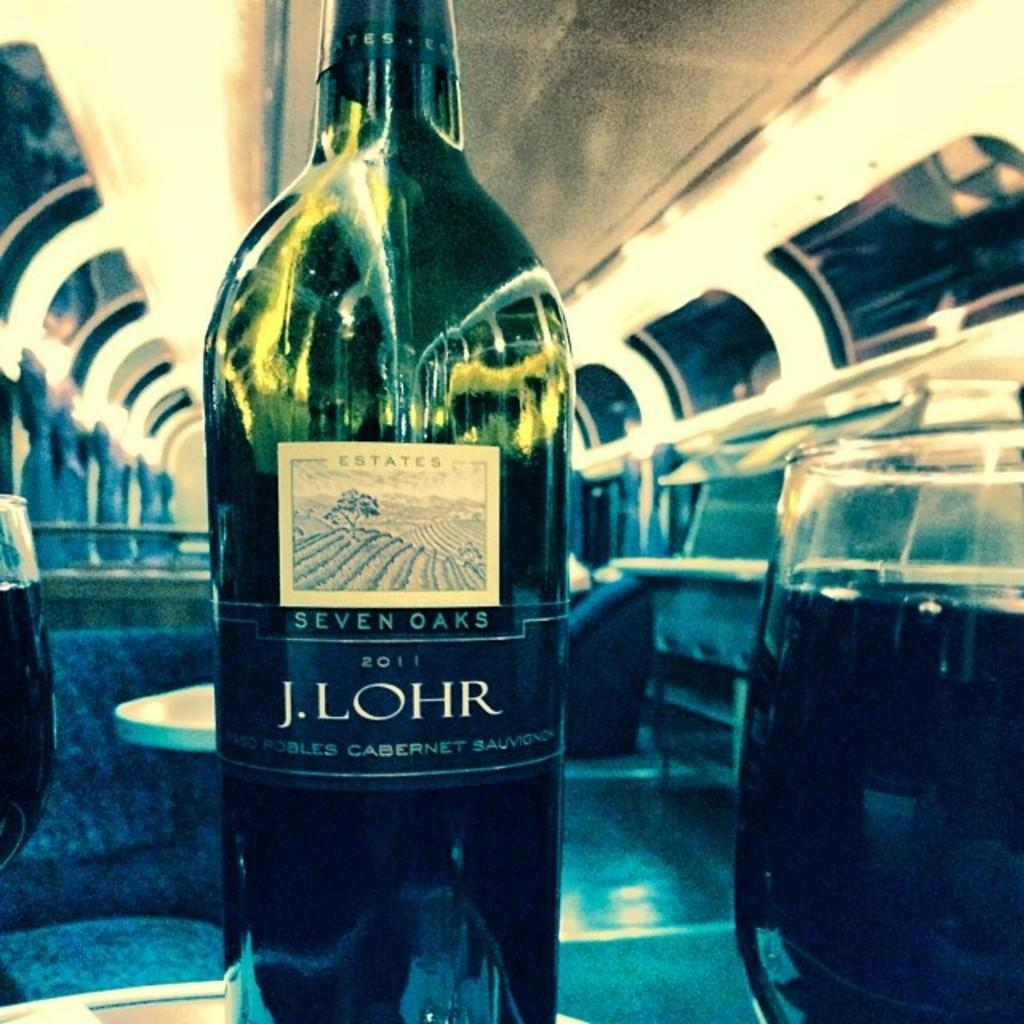<image>
Render a clear and concise summary of the photo. A bottle of Cabernet Sauvignon is produced by Seven Oaks Estates. 